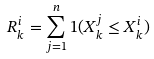Convert formula to latex. <formula><loc_0><loc_0><loc_500><loc_500>R _ { k } ^ { i } = \sum _ { j = 1 } ^ { n } 1 ( X _ { k } ^ { j } \leq X _ { k } ^ { i } )</formula> 